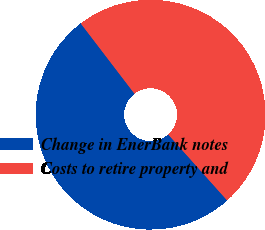Convert chart to OTSL. <chart><loc_0><loc_0><loc_500><loc_500><pie_chart><fcel>Change in EnerBank notes<fcel>Costs to retire property and<nl><fcel>51.22%<fcel>48.78%<nl></chart> 